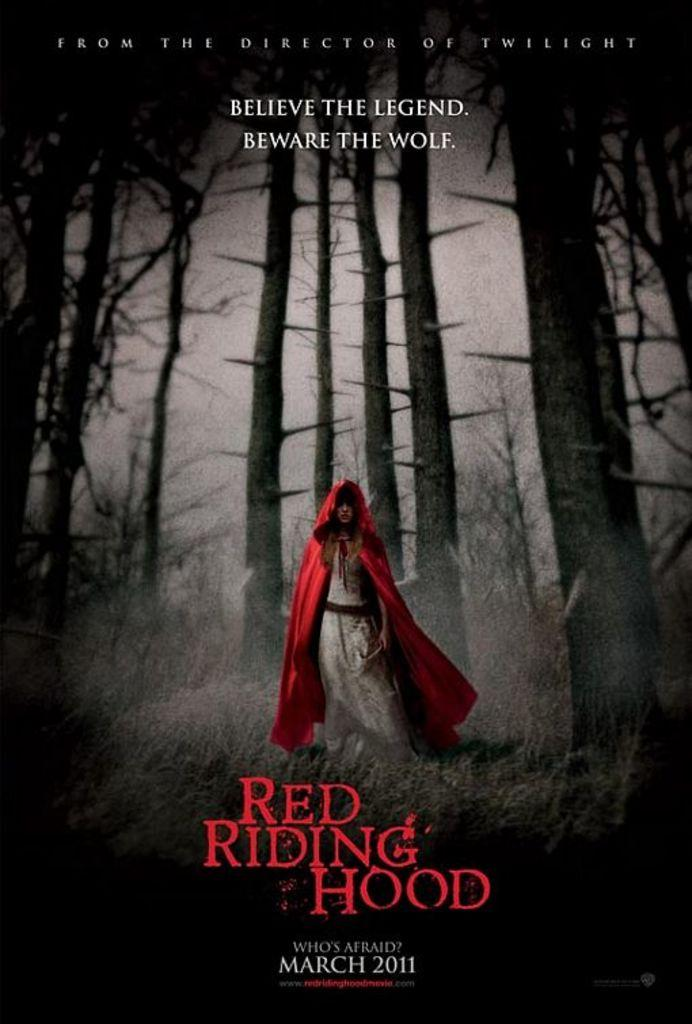<image>
Write a terse but informative summary of the picture. the poster for a movie called 'red riding hood' 